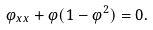<formula> <loc_0><loc_0><loc_500><loc_500>\varphi _ { x x } + \varphi ( 1 - \varphi ^ { 2 } ) = 0 .</formula> 